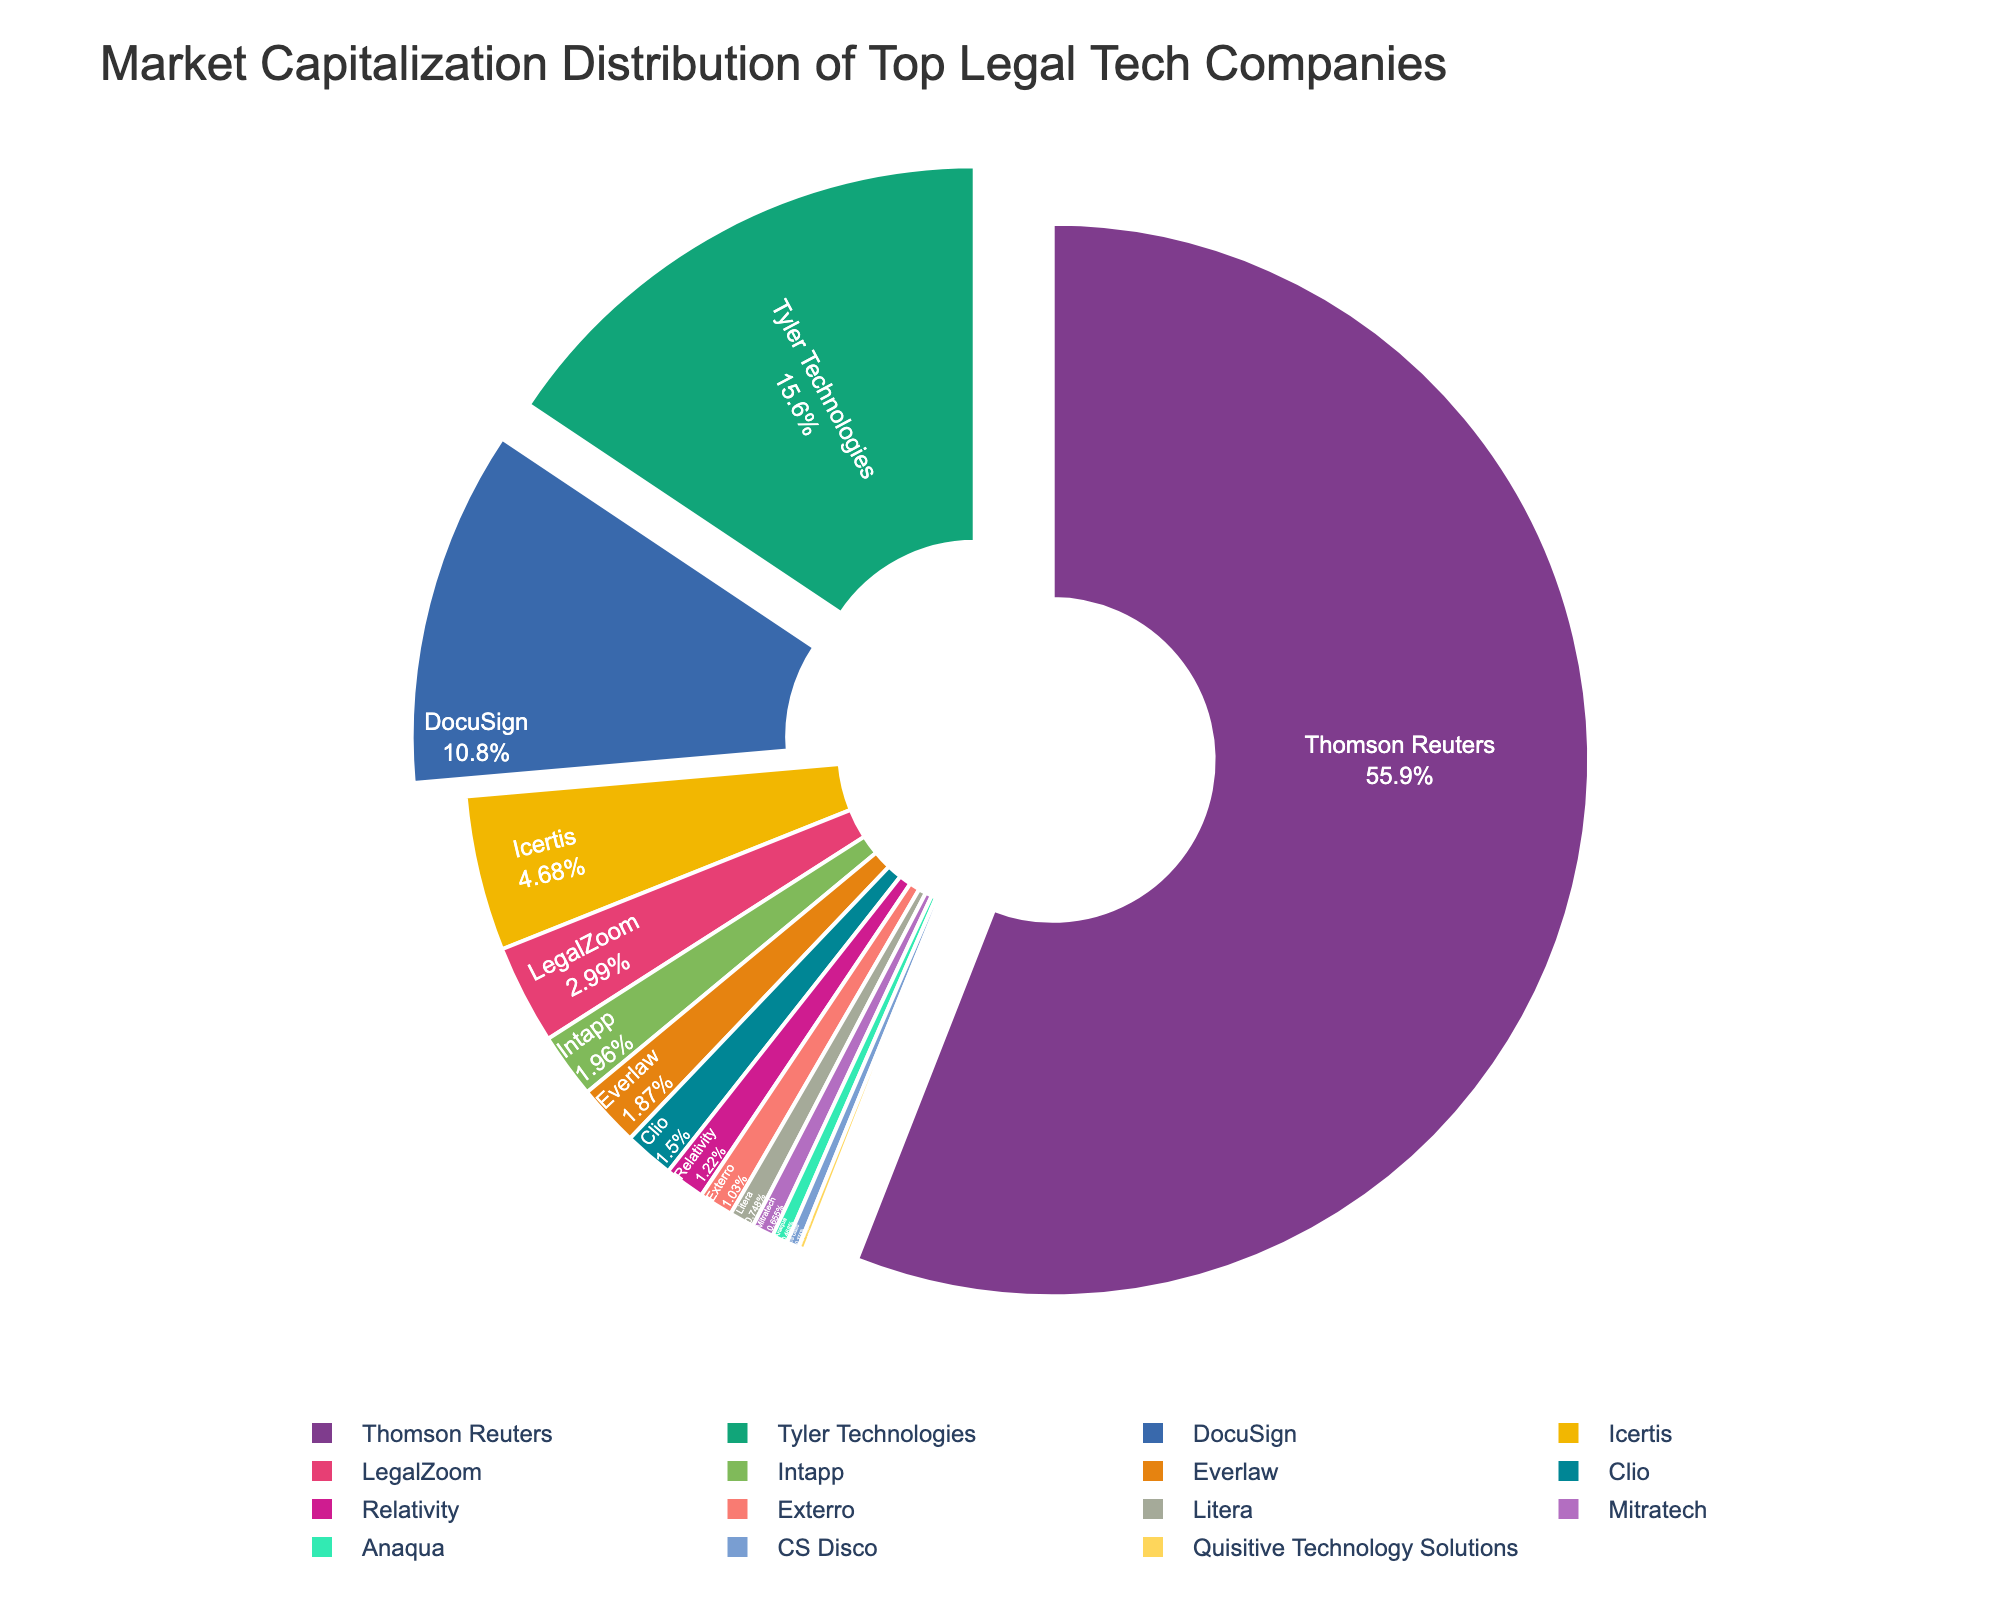Which company has the highest market capitalization, and what is its value? The figure shows a pie chart with different slices representing the market cap of each company; the largest slice corresponds to Thomson Reuters. The specific value is given in the chart's legend or label directly.
Answer: Thomson Reuters, 59.8 billion USD Which companies have a combined market cap greater than 60 billion USD? To find this, add the market cap values of multiple companies until the sum exceeds 60 billion USD. Thomson Reuters (59.8 billion USD) alone does not exceed 60 billion USD, so you need to add another company's market cap value to Thomson Reuters's value.
Answer: Thomson Reuters and Tyler Technologies How does the market cap of LegalZoom compare to that of DocuSign? The pie chart visually indicates the relative sizes of LegalZoom and DocuSign. From the chart, DocuSign’s slice is larger, indicating a higher market cap.
Answer: DocuSign has a higher market cap than LegalZoom What is the total market cap represented by all the companies in the pie chart? Sum the market cap values of all listed companies: 59.8 + 3.2 + 11.5 + 2.1 + 16.7 + 0.2 + 0.4 + 1.6 + 1.3 + 5.0 + 2.0 + 1.1 + 0.8 + 0.7 + 0.5.
Answer: 106.9 billion USD Which company has the smallest market cap, and what is its value? The smallest slice on the pie chart corresponds to the company with the smallest market cap. According to the legend, this is Quisitive Technology Solutions.
Answer: Quisitive Technology Solutions, 0.2 billion USD What percentage of the total market cap is held by the top three companies? Add the market caps of the top three companies (Thomson Reuters, Tyler Technologies, and DocuSign) and determine what percentage this is of the total, 59.8 + 16.7 + 11.5 = 88.0. Then calculate (88.0 / 106.9) * 100%.
Answer: Approximately 82.4% Which companies' market caps sum up to approximately half of the total market cap? Identify companies whose combined market caps amount to around 53.45 billion USD (which is approximately half of 106.9 billion USD). Thomson Reuters alone is close, but include Tyler Technologies to get a sum of 59.8 + 16.7 = 76.5, which exceeds half. Try another combination like DocuSign + Tyler Technologies + Icertis.
Answer: Thomson Reuters alone is closest, 59.8 billion USD, slightly more than half Is the market cap of Intapp more than double that of Exterro? Check both values from the pie chart. Intapp has a market cap of 2.1 billion USD, and Exterro has 1.1 billion USD. Since 2.1 is not more than double 1.1, the answer is no.
Answer: No What is the difference between the market cap of the highest and lowest companies? Subtract the smallest market cap value from the largest one: 59.8 (Thomson Reuters) - 0.2 (Quisitive Technology Solutions) = 59.6 billion USD.
Answer: 59.6 billion USD What is the combined market cap of companies whose market caps are less than 2 billion USD? Sum the market caps of all companies with a market cap less than 2 billion USD: Quisitive Technology Solutions (0.2), CS Disco (0.4), Clio (1.6), Relativity (1.3), Everlaw (2.0), Exterro (1.1), Litera (0.8), Mitratech (0.7), Anaqua (0.5). Calculate the sum: 0.2 + 0.4 + 1.6 + 1.3 + 1.1 + 0.8 + 0.7 + 0.5 = 6.6 (without Everlaw).
Answer: 6.6 billion USD 